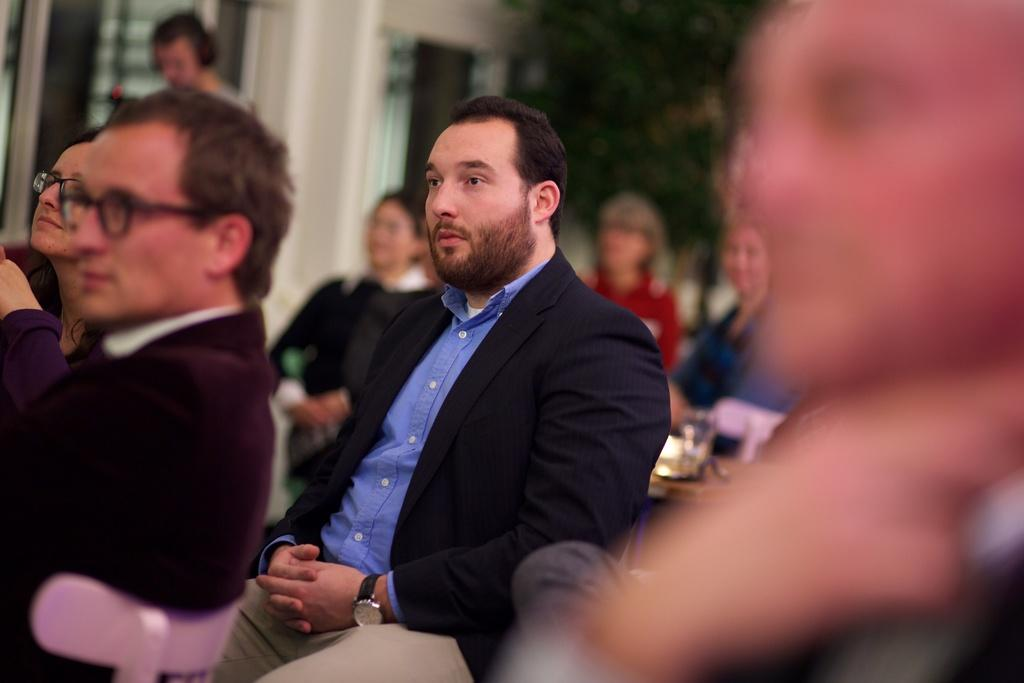What is the man in the image doing? The man is sitting in the image. What is the man wearing on his upper body? The man is wearing a black coat and a blue shirt. Are there any other people in the image? Yes, there are people sitting around the man. What type of crib is visible in the image? There is no crib present in the image. How is the distribution of people arranged around the man? The image does not provide information about the specific arrangement of people around the man. 